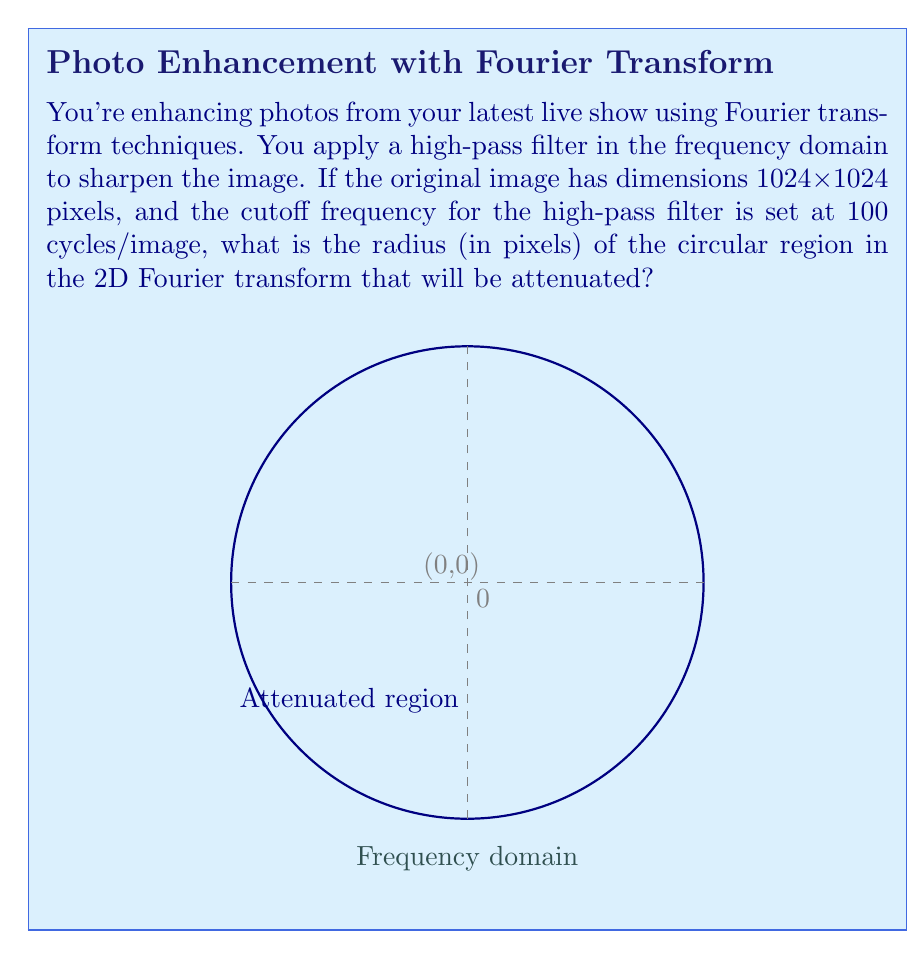What is the answer to this math problem? Let's approach this step-by-step:

1) In the 2D Fourier transform of an image, the center (0,0) represents the DC component (zero frequency), and the distance from the center represents increasing frequencies.

2) The dimensions of the frequency domain match the dimensions of the spatial domain. For a 1024x1024 image, the frequency domain is also 1024x1024.

3) The Nyquist frequency (highest representable frequency) is half the sampling rate. In this case, it's 512 cycles/image (1024/2).

4) The relationship between spatial frequency (f) and distance from the center (r) in the frequency domain is:

   $$f = \frac{r}{N} \cdot f_{Nyquist}$$

   where N is the image dimension (1024 in this case).

5) We want to solve for r when f = 100 cycles/image:

   $$100 = \frac{r}{1024} \cdot 512$$

6) Rearranging the equation:

   $$r = \frac{100 \cdot 1024}{512} = 200$$

Therefore, the radius of the circular region to be attenuated is 200 pixels.
Answer: 200 pixels 